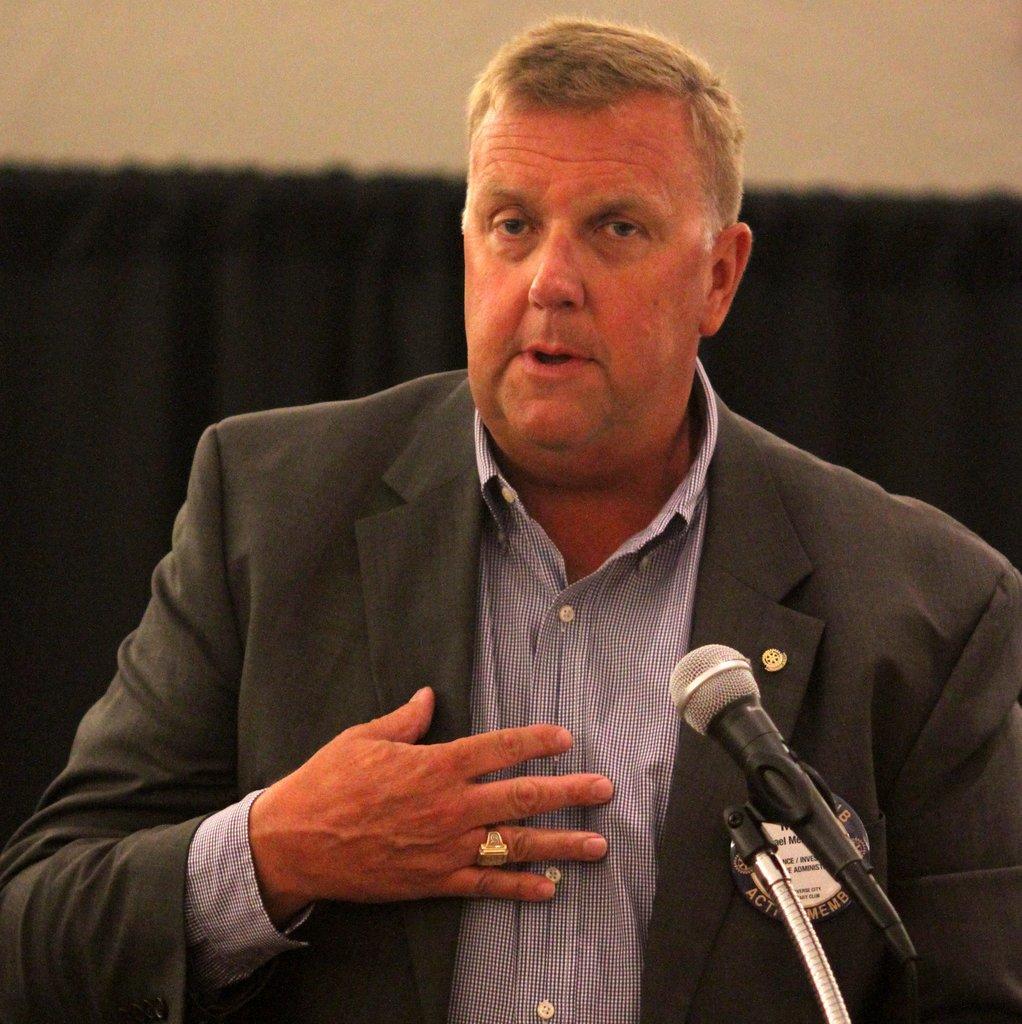Can you describe this image briefly? In this picture I can see a man talking, on the right side there is the microphone. 